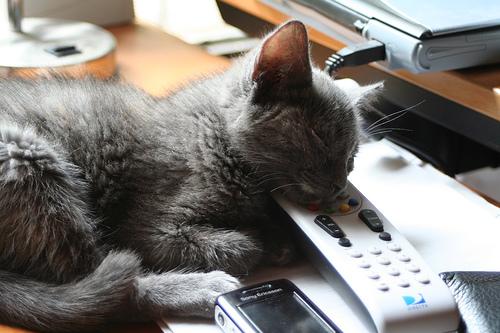How many phones are in the picture?
Keep it brief. 1. Is the animal in a cage?
Quick response, please. No. What is the brand name of the remote control?
Answer briefly. Direct tv. 